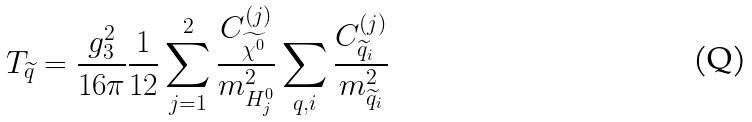Convert formula to latex. <formula><loc_0><loc_0><loc_500><loc_500>T _ { \widetilde { q } } = \frac { g ^ { 2 } _ { 3 } } { 1 6 \pi } \frac { 1 } { 1 2 } \sum _ { j = 1 } ^ { 2 } \frac { C ^ { ( j ) } _ { \widetilde { \chi ^ { 0 } } } } { m ^ { 2 } _ { H ^ { 0 } _ { j } } } \sum _ { q , i } \frac { C ^ { ( j ) } _ { \widetilde { q } _ { i } } } { m ^ { 2 } _ { \widetilde { q } _ { i } } }</formula> 